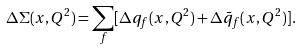<formula> <loc_0><loc_0><loc_500><loc_500>\Delta \Sigma ( x , Q ^ { 2 } ) = \sum _ { f } [ \Delta q _ { f } ( x , Q ^ { 2 } ) + \Delta \bar { q } _ { f } ( x , Q ^ { 2 } ) ] .</formula> 